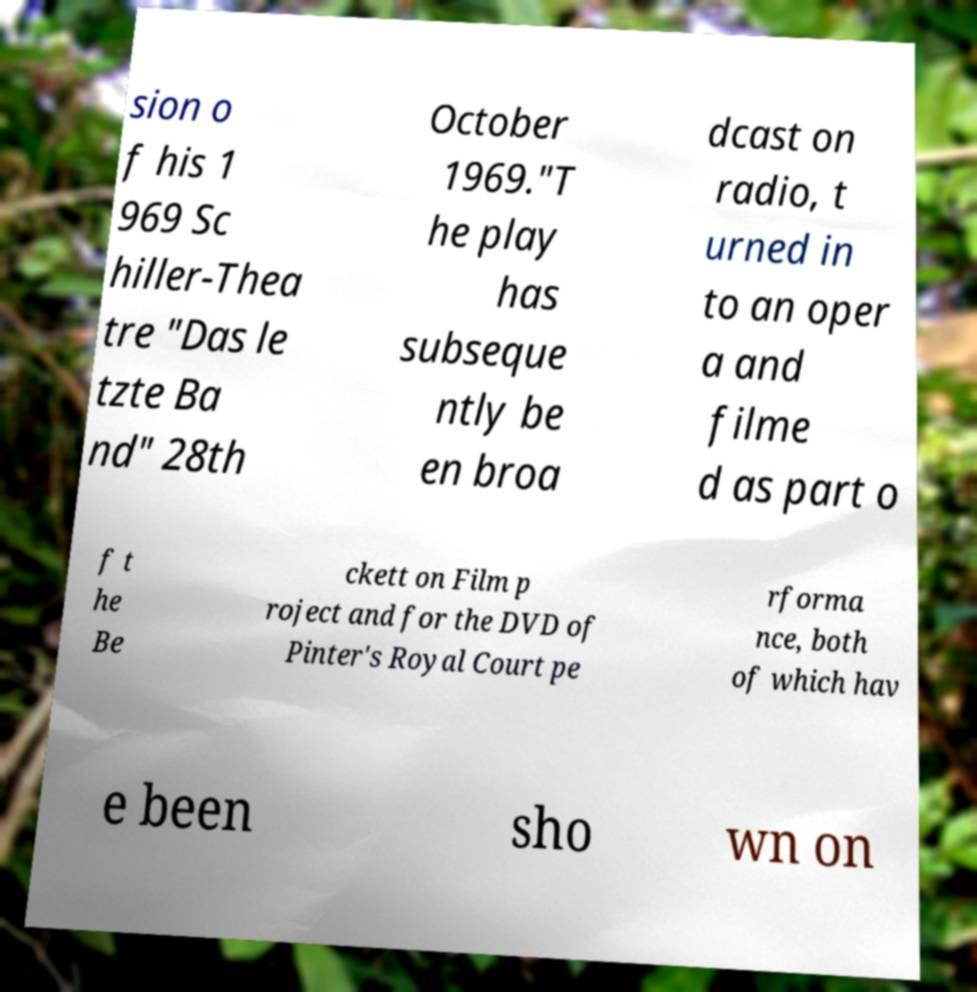I need the written content from this picture converted into text. Can you do that? sion o f his 1 969 Sc hiller-Thea tre "Das le tzte Ba nd" 28th October 1969."T he play has subseque ntly be en broa dcast on radio, t urned in to an oper a and filme d as part o f t he Be ckett on Film p roject and for the DVD of Pinter's Royal Court pe rforma nce, both of which hav e been sho wn on 